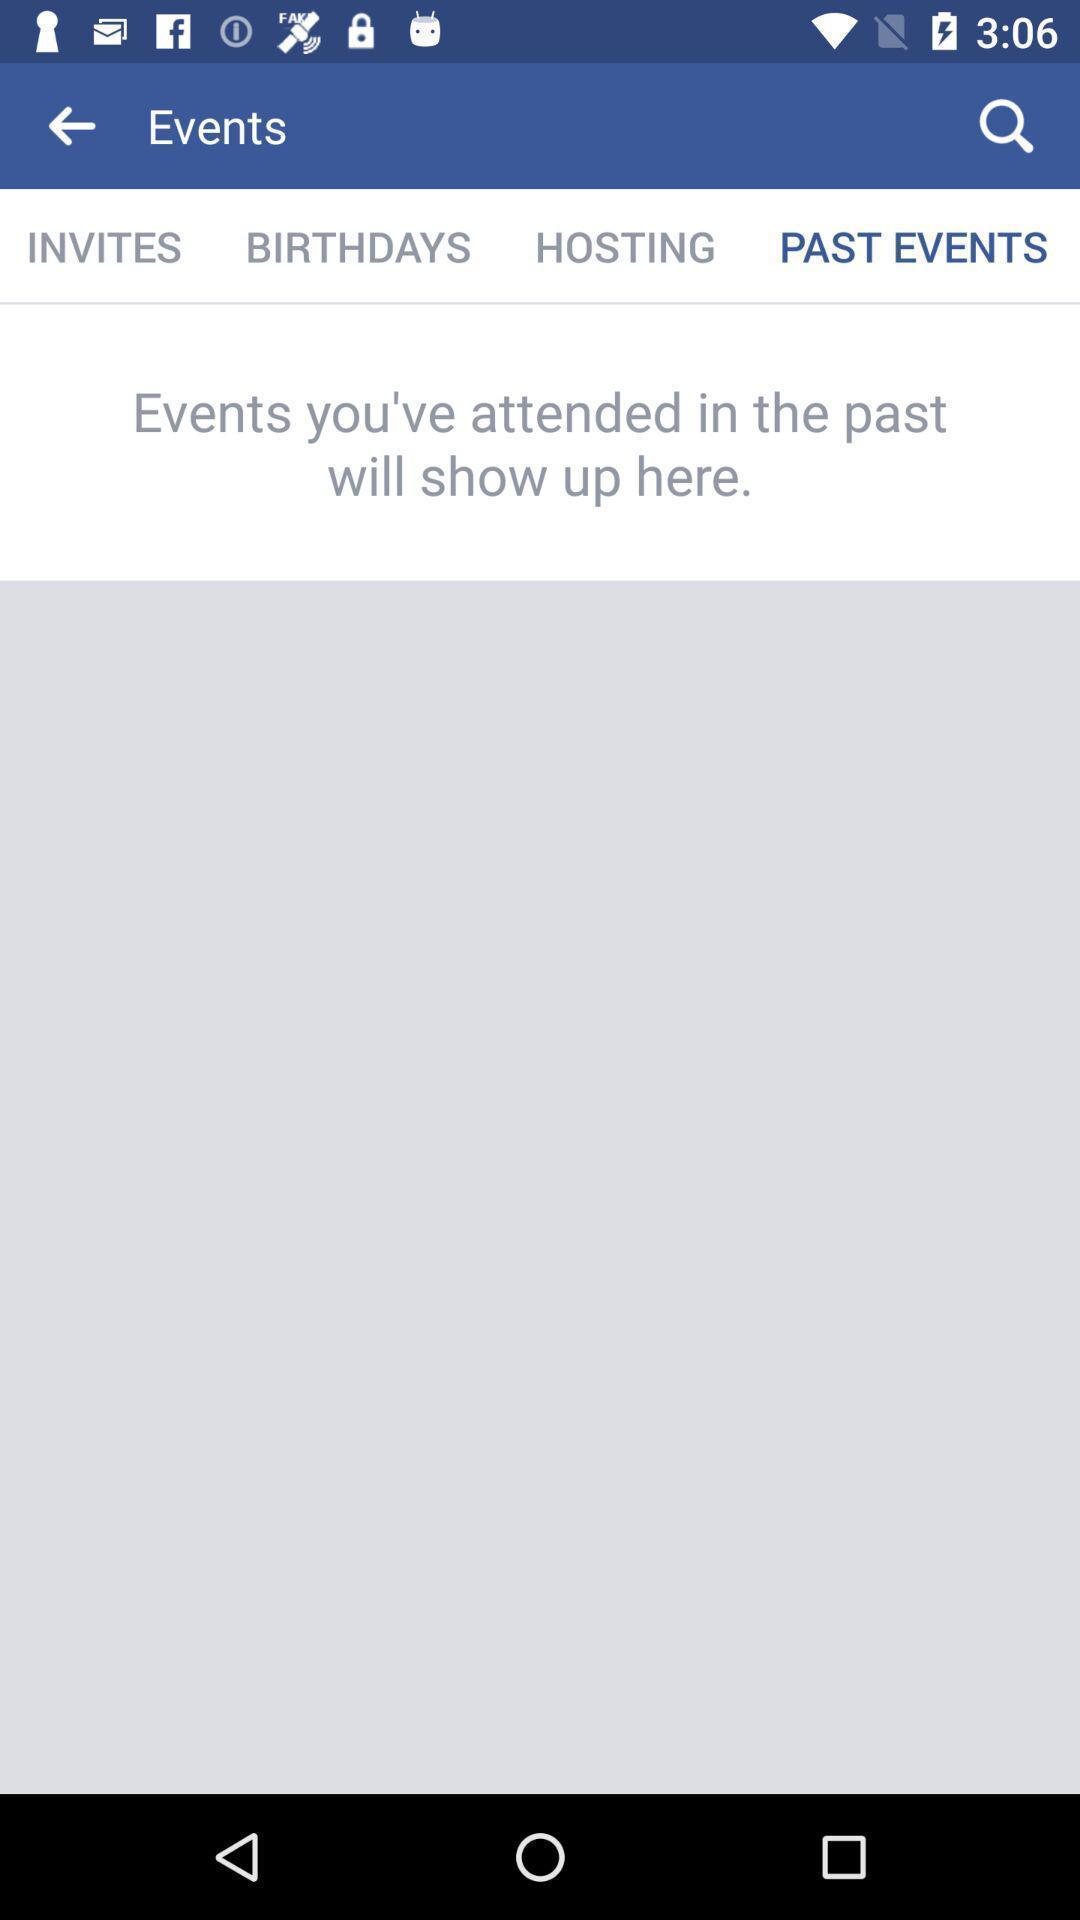Give me a narrative description of this picture. Page showing your past events in the social app. 